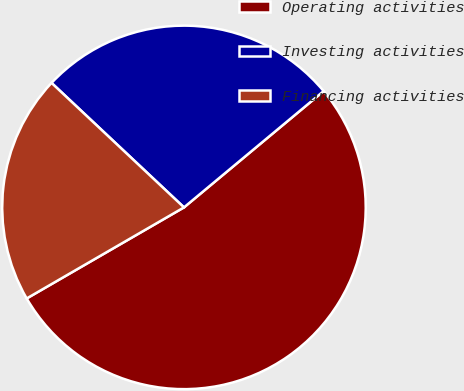Convert chart to OTSL. <chart><loc_0><loc_0><loc_500><loc_500><pie_chart><fcel>Operating activities<fcel>Investing activities<fcel>Financing activities<nl><fcel>52.7%<fcel>26.94%<fcel>20.36%<nl></chart> 